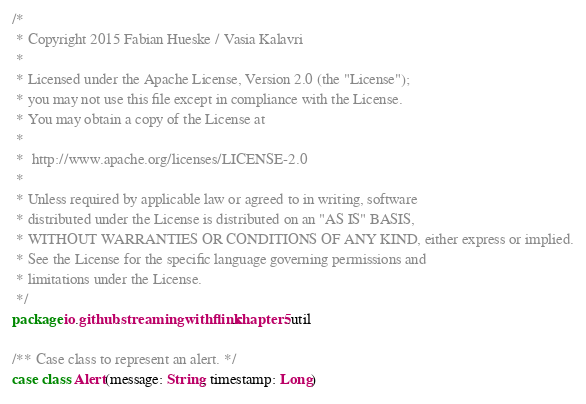Convert code to text. <code><loc_0><loc_0><loc_500><loc_500><_Scala_>/*
 * Copyright 2015 Fabian Hueske / Vasia Kalavri
 *
 * Licensed under the Apache License, Version 2.0 (the "License");
 * you may not use this file except in compliance with the License.
 * You may obtain a copy of the License at
 *
 *  http://www.apache.org/licenses/LICENSE-2.0
 *
 * Unless required by applicable law or agreed to in writing, software
 * distributed under the License is distributed on an "AS IS" BASIS,
 * WITHOUT WARRANTIES OR CONDITIONS OF ANY KIND, either express or implied.
 * See the License for the specific language governing permissions and
 * limitations under the License.
 */
package io.github.streamingwithflink.chapter5.util

/** Case class to represent an alert. */
case class Alert(message: String, timestamp: Long)
</code> 